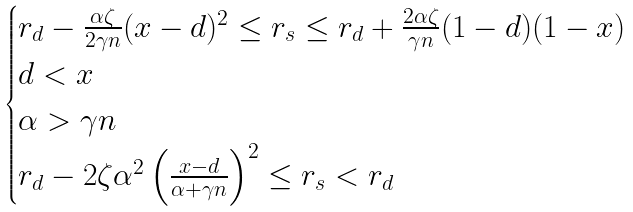Convert formula to latex. <formula><loc_0><loc_0><loc_500><loc_500>\begin{cases} r _ { d } - \frac { \alpha \zeta } { 2 \gamma n } ( x - d ) ^ { 2 } \leq r _ { s } \leq r _ { d } + \frac { 2 \alpha \zeta } { \gamma n } ( 1 - d ) ( 1 - x ) \\ d < x \\ \alpha > \gamma n \\ r _ { d } - 2 \zeta \alpha ^ { 2 } \left ( \frac { x - d } { \alpha + \gamma n } \right ) ^ { 2 } \leq r _ { s } < r _ { d } \end{cases}</formula> 